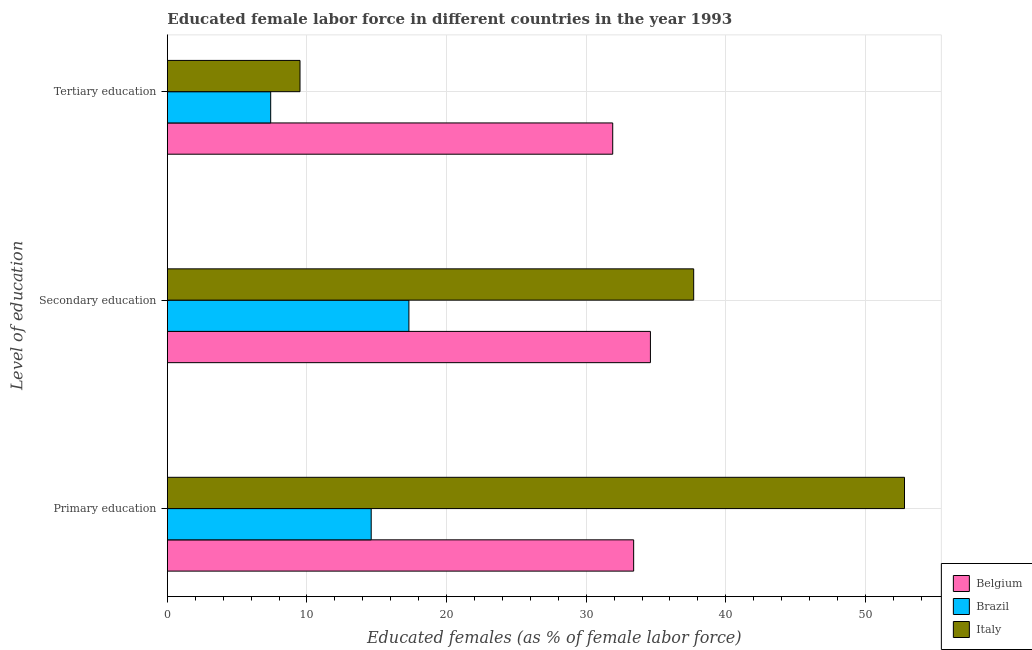How many bars are there on the 2nd tick from the top?
Make the answer very short. 3. How many bars are there on the 1st tick from the bottom?
Your answer should be compact. 3. What is the label of the 2nd group of bars from the top?
Provide a succinct answer. Secondary education. What is the percentage of female labor force who received primary education in Belgium?
Your answer should be very brief. 33.4. Across all countries, what is the maximum percentage of female labor force who received tertiary education?
Your answer should be very brief. 31.9. Across all countries, what is the minimum percentage of female labor force who received tertiary education?
Provide a short and direct response. 7.4. In which country was the percentage of female labor force who received primary education maximum?
Provide a succinct answer. Italy. In which country was the percentage of female labor force who received primary education minimum?
Give a very brief answer. Brazil. What is the total percentage of female labor force who received primary education in the graph?
Ensure brevity in your answer.  100.8. What is the difference between the percentage of female labor force who received tertiary education in Italy and that in Brazil?
Your answer should be very brief. 2.1. What is the difference between the percentage of female labor force who received tertiary education in Belgium and the percentage of female labor force who received primary education in Italy?
Offer a very short reply. -20.9. What is the average percentage of female labor force who received primary education per country?
Provide a short and direct response. 33.6. What is the difference between the percentage of female labor force who received tertiary education and percentage of female labor force who received secondary education in Italy?
Offer a very short reply. -28.2. What is the ratio of the percentage of female labor force who received primary education in Italy to that in Brazil?
Your answer should be compact. 3.62. Is the percentage of female labor force who received secondary education in Belgium less than that in Brazil?
Your answer should be very brief. No. Is the difference between the percentage of female labor force who received tertiary education in Belgium and Italy greater than the difference between the percentage of female labor force who received primary education in Belgium and Italy?
Make the answer very short. Yes. What is the difference between the highest and the second highest percentage of female labor force who received primary education?
Ensure brevity in your answer.  19.4. What is the difference between the highest and the lowest percentage of female labor force who received secondary education?
Make the answer very short. 20.4. In how many countries, is the percentage of female labor force who received tertiary education greater than the average percentage of female labor force who received tertiary education taken over all countries?
Provide a succinct answer. 1. Is the sum of the percentage of female labor force who received secondary education in Belgium and Brazil greater than the maximum percentage of female labor force who received tertiary education across all countries?
Give a very brief answer. Yes. What does the 2nd bar from the bottom in Secondary education represents?
Give a very brief answer. Brazil. How many bars are there?
Your answer should be compact. 9. How many countries are there in the graph?
Offer a terse response. 3. What is the difference between two consecutive major ticks on the X-axis?
Your answer should be compact. 10. Are the values on the major ticks of X-axis written in scientific E-notation?
Your answer should be compact. No. How many legend labels are there?
Offer a very short reply. 3. What is the title of the graph?
Offer a terse response. Educated female labor force in different countries in the year 1993. Does "St. Martin (French part)" appear as one of the legend labels in the graph?
Give a very brief answer. No. What is the label or title of the X-axis?
Give a very brief answer. Educated females (as % of female labor force). What is the label or title of the Y-axis?
Keep it short and to the point. Level of education. What is the Educated females (as % of female labor force) in Belgium in Primary education?
Offer a very short reply. 33.4. What is the Educated females (as % of female labor force) in Brazil in Primary education?
Offer a terse response. 14.6. What is the Educated females (as % of female labor force) in Italy in Primary education?
Your answer should be very brief. 52.8. What is the Educated females (as % of female labor force) of Belgium in Secondary education?
Your answer should be compact. 34.6. What is the Educated females (as % of female labor force) in Brazil in Secondary education?
Give a very brief answer. 17.3. What is the Educated females (as % of female labor force) of Italy in Secondary education?
Ensure brevity in your answer.  37.7. What is the Educated females (as % of female labor force) of Belgium in Tertiary education?
Your answer should be very brief. 31.9. What is the Educated females (as % of female labor force) of Brazil in Tertiary education?
Your answer should be compact. 7.4. Across all Level of education, what is the maximum Educated females (as % of female labor force) of Belgium?
Your answer should be very brief. 34.6. Across all Level of education, what is the maximum Educated females (as % of female labor force) of Brazil?
Your response must be concise. 17.3. Across all Level of education, what is the maximum Educated females (as % of female labor force) of Italy?
Your answer should be very brief. 52.8. Across all Level of education, what is the minimum Educated females (as % of female labor force) in Belgium?
Provide a short and direct response. 31.9. Across all Level of education, what is the minimum Educated females (as % of female labor force) in Brazil?
Your answer should be very brief. 7.4. Across all Level of education, what is the minimum Educated females (as % of female labor force) of Italy?
Your answer should be very brief. 9.5. What is the total Educated females (as % of female labor force) in Belgium in the graph?
Your response must be concise. 99.9. What is the total Educated females (as % of female labor force) in Brazil in the graph?
Give a very brief answer. 39.3. What is the difference between the Educated females (as % of female labor force) of Belgium in Primary education and that in Secondary education?
Provide a short and direct response. -1.2. What is the difference between the Educated females (as % of female labor force) of Brazil in Primary education and that in Secondary education?
Keep it short and to the point. -2.7. What is the difference between the Educated females (as % of female labor force) in Belgium in Primary education and that in Tertiary education?
Offer a terse response. 1.5. What is the difference between the Educated females (as % of female labor force) of Italy in Primary education and that in Tertiary education?
Your response must be concise. 43.3. What is the difference between the Educated females (as % of female labor force) in Belgium in Secondary education and that in Tertiary education?
Give a very brief answer. 2.7. What is the difference between the Educated females (as % of female labor force) in Brazil in Secondary education and that in Tertiary education?
Provide a succinct answer. 9.9. What is the difference between the Educated females (as % of female labor force) in Italy in Secondary education and that in Tertiary education?
Your answer should be compact. 28.2. What is the difference between the Educated females (as % of female labor force) in Belgium in Primary education and the Educated females (as % of female labor force) in Italy in Secondary education?
Give a very brief answer. -4.3. What is the difference between the Educated females (as % of female labor force) of Brazil in Primary education and the Educated females (as % of female labor force) of Italy in Secondary education?
Give a very brief answer. -23.1. What is the difference between the Educated females (as % of female labor force) in Belgium in Primary education and the Educated females (as % of female labor force) in Italy in Tertiary education?
Your answer should be very brief. 23.9. What is the difference between the Educated females (as % of female labor force) in Brazil in Primary education and the Educated females (as % of female labor force) in Italy in Tertiary education?
Your answer should be very brief. 5.1. What is the difference between the Educated females (as % of female labor force) of Belgium in Secondary education and the Educated females (as % of female labor force) of Brazil in Tertiary education?
Your response must be concise. 27.2. What is the difference between the Educated females (as % of female labor force) in Belgium in Secondary education and the Educated females (as % of female labor force) in Italy in Tertiary education?
Make the answer very short. 25.1. What is the average Educated females (as % of female labor force) in Belgium per Level of education?
Provide a short and direct response. 33.3. What is the average Educated females (as % of female labor force) of Brazil per Level of education?
Your response must be concise. 13.1. What is the average Educated females (as % of female labor force) in Italy per Level of education?
Your answer should be very brief. 33.33. What is the difference between the Educated females (as % of female labor force) of Belgium and Educated females (as % of female labor force) of Brazil in Primary education?
Ensure brevity in your answer.  18.8. What is the difference between the Educated females (as % of female labor force) of Belgium and Educated females (as % of female labor force) of Italy in Primary education?
Ensure brevity in your answer.  -19.4. What is the difference between the Educated females (as % of female labor force) of Brazil and Educated females (as % of female labor force) of Italy in Primary education?
Make the answer very short. -38.2. What is the difference between the Educated females (as % of female labor force) of Belgium and Educated females (as % of female labor force) of Brazil in Secondary education?
Offer a terse response. 17.3. What is the difference between the Educated females (as % of female labor force) of Belgium and Educated females (as % of female labor force) of Italy in Secondary education?
Keep it short and to the point. -3.1. What is the difference between the Educated females (as % of female labor force) in Brazil and Educated females (as % of female labor force) in Italy in Secondary education?
Make the answer very short. -20.4. What is the difference between the Educated females (as % of female labor force) in Belgium and Educated females (as % of female labor force) in Italy in Tertiary education?
Your answer should be compact. 22.4. What is the difference between the Educated females (as % of female labor force) of Brazil and Educated females (as % of female labor force) of Italy in Tertiary education?
Your answer should be very brief. -2.1. What is the ratio of the Educated females (as % of female labor force) in Belgium in Primary education to that in Secondary education?
Make the answer very short. 0.97. What is the ratio of the Educated females (as % of female labor force) in Brazil in Primary education to that in Secondary education?
Provide a short and direct response. 0.84. What is the ratio of the Educated females (as % of female labor force) of Italy in Primary education to that in Secondary education?
Your answer should be very brief. 1.4. What is the ratio of the Educated females (as % of female labor force) in Belgium in Primary education to that in Tertiary education?
Provide a short and direct response. 1.05. What is the ratio of the Educated females (as % of female labor force) of Brazil in Primary education to that in Tertiary education?
Keep it short and to the point. 1.97. What is the ratio of the Educated females (as % of female labor force) in Italy in Primary education to that in Tertiary education?
Your answer should be compact. 5.56. What is the ratio of the Educated females (as % of female labor force) in Belgium in Secondary education to that in Tertiary education?
Offer a very short reply. 1.08. What is the ratio of the Educated females (as % of female labor force) in Brazil in Secondary education to that in Tertiary education?
Your response must be concise. 2.34. What is the ratio of the Educated females (as % of female labor force) of Italy in Secondary education to that in Tertiary education?
Provide a succinct answer. 3.97. What is the difference between the highest and the second highest Educated females (as % of female labor force) in Brazil?
Make the answer very short. 2.7. What is the difference between the highest and the lowest Educated females (as % of female labor force) of Belgium?
Your answer should be compact. 2.7. What is the difference between the highest and the lowest Educated females (as % of female labor force) of Brazil?
Make the answer very short. 9.9. What is the difference between the highest and the lowest Educated females (as % of female labor force) in Italy?
Provide a short and direct response. 43.3. 